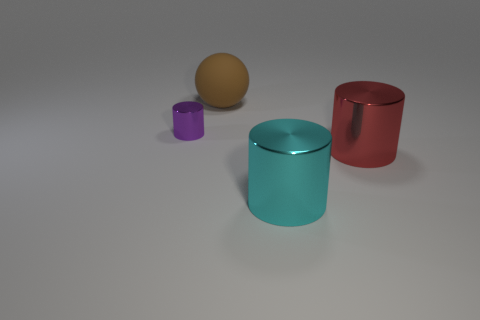Subtract all big red metallic cylinders. How many cylinders are left? 2 Add 4 big rubber things. How many objects exist? 8 Subtract all cylinders. How many objects are left? 1 Subtract all cyan cylinders. Subtract all brown blocks. How many cylinders are left? 2 Subtract all big brown things. Subtract all cyan cubes. How many objects are left? 3 Add 3 big cyan cylinders. How many big cyan cylinders are left? 4 Add 4 small purple shiny cylinders. How many small purple shiny cylinders exist? 5 Subtract 0 brown cylinders. How many objects are left? 4 